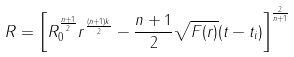Convert formula to latex. <formula><loc_0><loc_0><loc_500><loc_500>R = \left [ R _ { 0 } ^ { \frac { n + 1 } { 2 } } r ^ { \frac { ( n + 1 ) k } { 2 } } - \frac { n + 1 } { 2 } \sqrt { F ( r ) } ( t - t _ { i } ) \right ] ^ { \frac { 2 } { n + 1 } }</formula> 